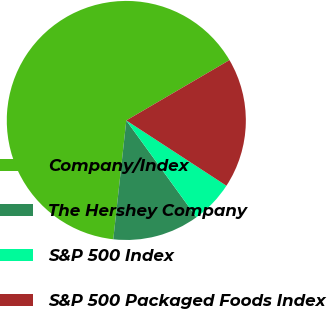Convert chart. <chart><loc_0><loc_0><loc_500><loc_500><pie_chart><fcel>Company/Index<fcel>The Hershey Company<fcel>S&P 500 Index<fcel>S&P 500 Packaged Foods Index<nl><fcel>64.83%<fcel>11.72%<fcel>5.82%<fcel>17.62%<nl></chart> 